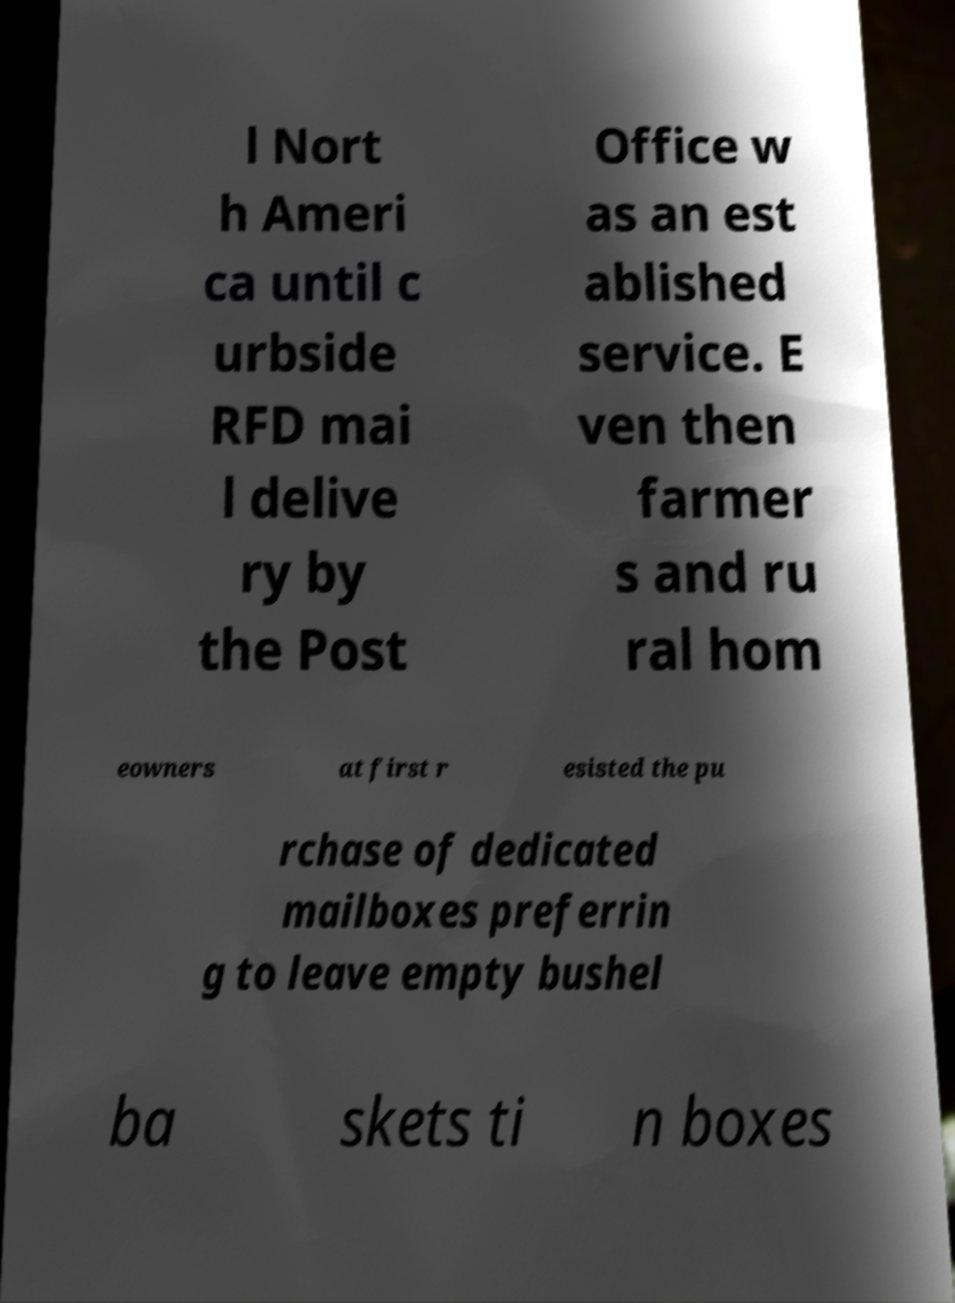Could you assist in decoding the text presented in this image and type it out clearly? l Nort h Ameri ca until c urbside RFD mai l delive ry by the Post Office w as an est ablished service. E ven then farmer s and ru ral hom eowners at first r esisted the pu rchase of dedicated mailboxes preferrin g to leave empty bushel ba skets ti n boxes 